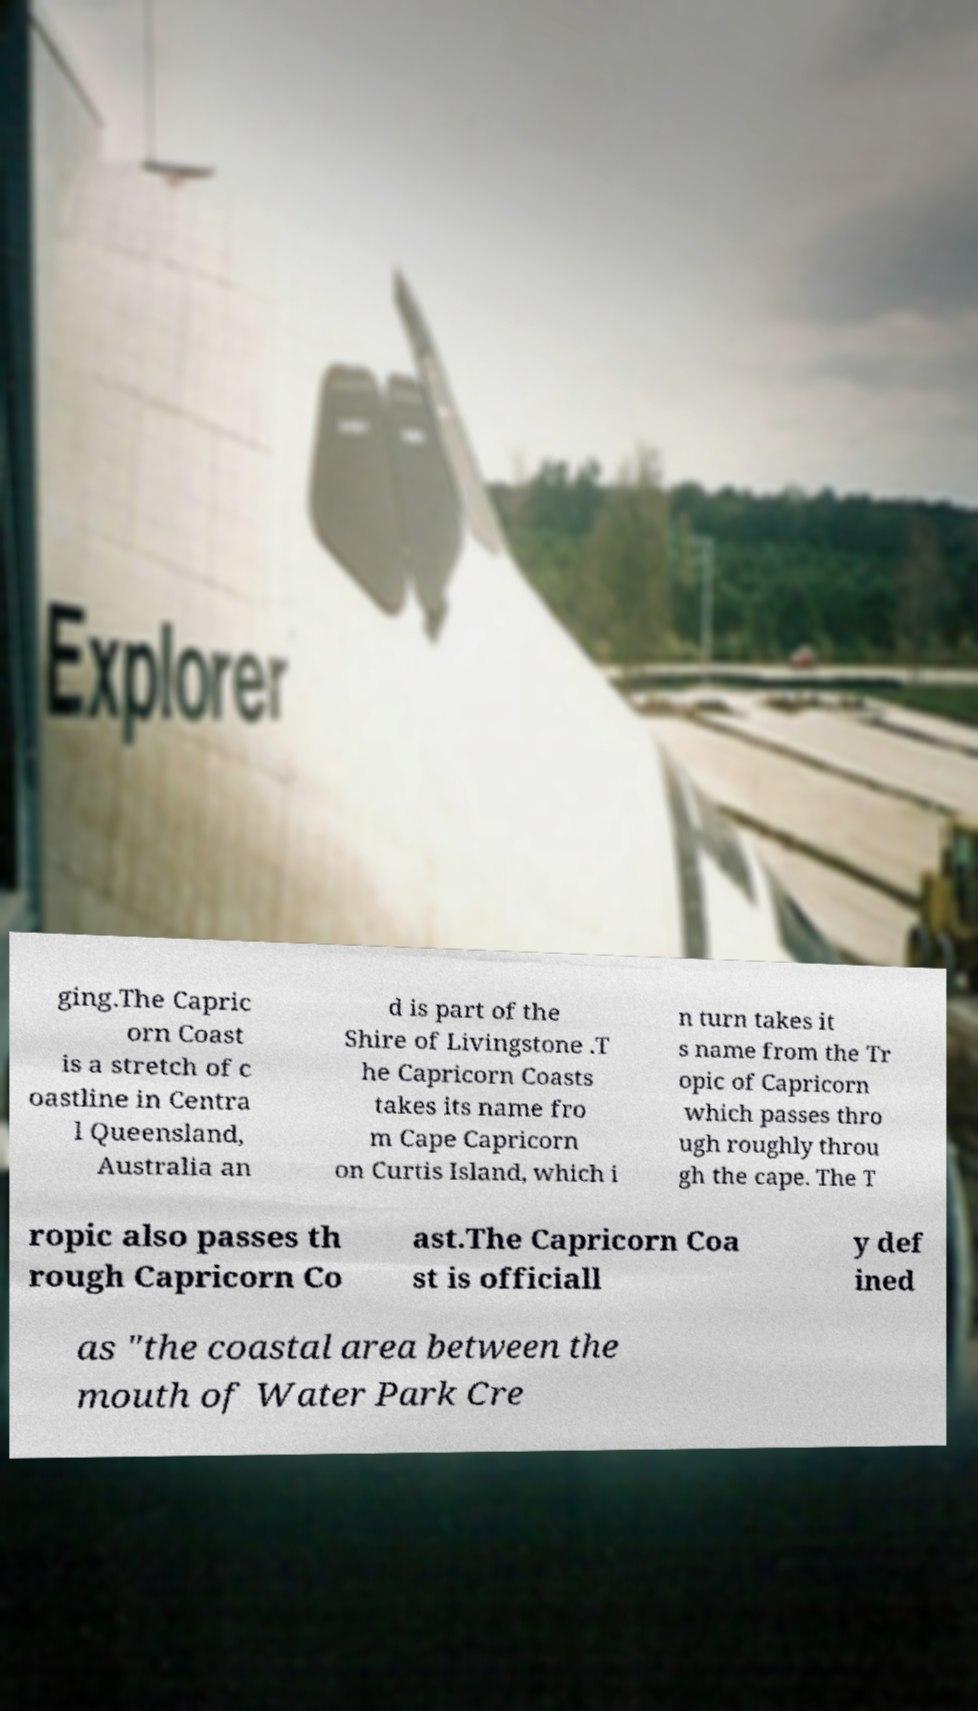Could you extract and type out the text from this image? ging.The Capric orn Coast is a stretch of c oastline in Centra l Queensland, Australia an d is part of the Shire of Livingstone .T he Capricorn Coasts takes its name fro m Cape Capricorn on Curtis Island, which i n turn takes it s name from the Tr opic of Capricorn which passes thro ugh roughly throu gh the cape. The T ropic also passes th rough Capricorn Co ast.The Capricorn Coa st is officiall y def ined as "the coastal area between the mouth of Water Park Cre 